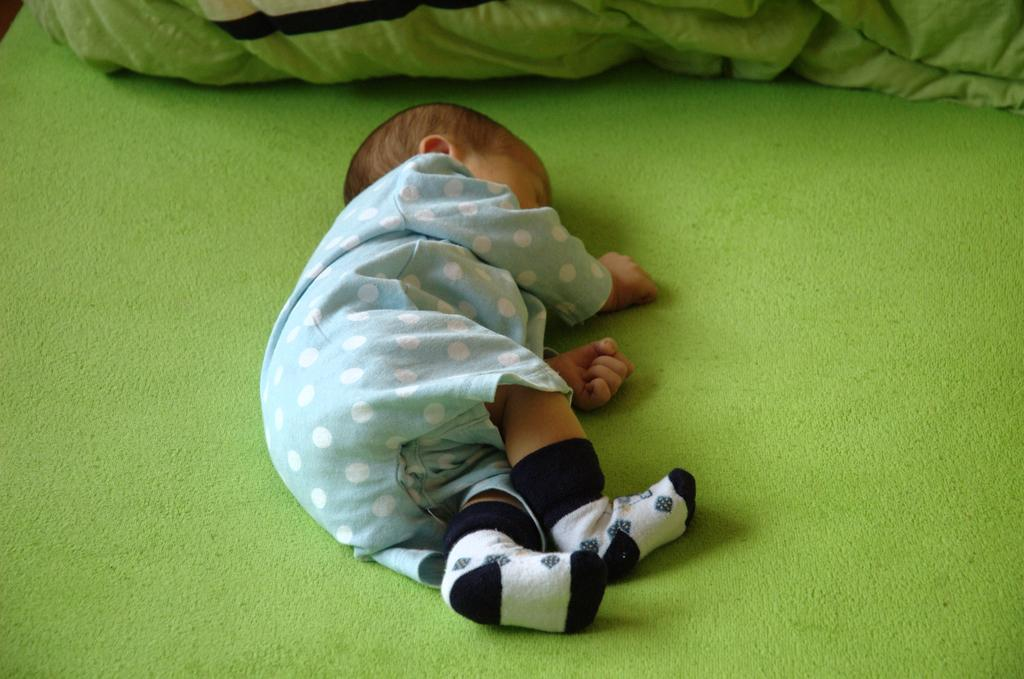What is the main subject of the picture? The main subject of the picture is a child. What is the child doing in the picture? The child is sleeping in the picture. What color is the surface the child is lying on? The child is on a green color surface. What color is the dress the child is wearing? The child is wearing a blue color dress. What type of footwear is the child wearing? The child is wearing socks. What religion does the child belong to in the image? There is no indication of the child's religion in the image. --- Facts: 1. There is a car in the image. 2. The car is red in color. 3. The car has four wheels. 4. The car is parked on the street. 5. There are people walking on the street. Absurd Topics: elephant, ocean Conversation: What is the main subject in the image? The main subject in the image is a car. What color is the car? The car is red in color. How many wheels does the car have? The car has four wheels. Where is the car located in the image? The car is parked on the street. What else can be seen in the image? There are people walking on the street. Reasoning: Let's think step by step in order to produce the conversation. We start by identifying the main subject of the image, which is the car. Next, we describe specific features of the car, such as the color and the number of wheels. Then, we observe the location of the car, which is parked on the street. Finally, we describe the surrounding environment, which includes people walking on the street. Absurd Question/Answer: Can you see an elephant swimming in the ocean in the image? There is no elephant or ocean present in the image. 